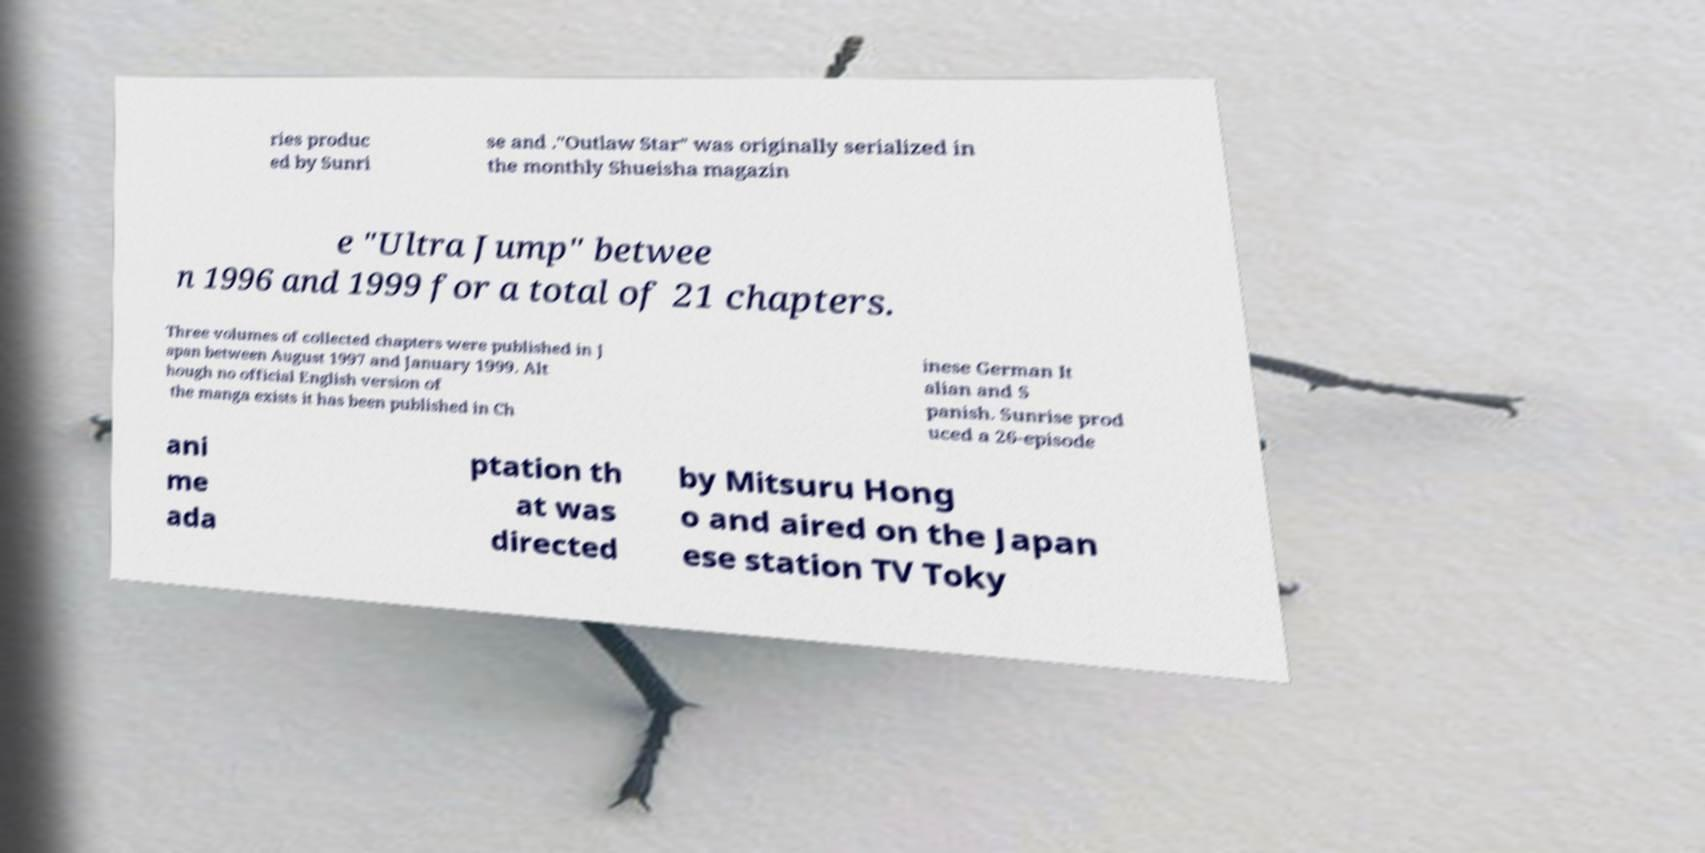What messages or text are displayed in this image? I need them in a readable, typed format. ries produc ed by Sunri se and ."Outlaw Star" was originally serialized in the monthly Shueisha magazin e "Ultra Jump" betwee n 1996 and 1999 for a total of 21 chapters. Three volumes of collected chapters were published in J apan between August 1997 and January 1999. Alt hough no official English version of the manga exists it has been published in Ch inese German It alian and S panish. Sunrise prod uced a 26-episode ani me ada ptation th at was directed by Mitsuru Hong o and aired on the Japan ese station TV Toky 